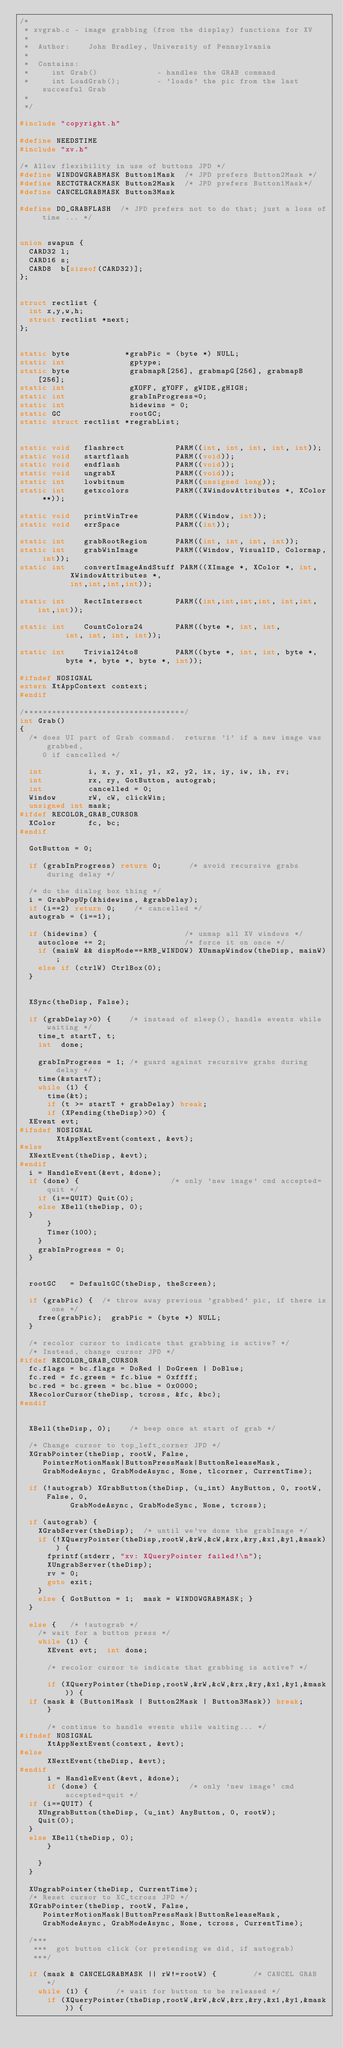Convert code to text. <code><loc_0><loc_0><loc_500><loc_500><_C_>/*
 * xvgrab.c - image grabbing (from the display) functions for XV
 *
 *  Author:    John Bradley, University of Pennsylvania
 *
 *  Contains:
 *     int Grab()             - handles the GRAB command
 *     int LoadGrab();        - 'loads' the pic from the last succesful Grab
 *
 */

#include "copyright.h"

#define NEEDSTIME
#include "xv.h"

/* Allow flexibility in use of buttons JPD */
#define WINDOWGRABMASK Button1Mask  /* JPD prefers Button2Mask */
#define RECTGTRACKMASK Button2Mask  /* JPD prefers Button1Mask*/
#define CANCELGRABMASK Button3Mask

#define DO_GRABFLASH  /* JPD prefers not to do that; just a loss of time ... */


union swapun {
  CARD32 l;
  CARD16 s;
  CARD8  b[sizeof(CARD32)];
};


struct rectlist {
  int x,y,w,h;
  struct rectlist *next;
};


static byte            *grabPic = (byte *) NULL;
static int              gptype;
static byte             grabmapR[256], grabmapG[256], grabmapB[256];
static int              gXOFF, gYOFF, gWIDE,gHIGH;
static int              grabInProgress=0;
static int              hidewins = 0;
static GC               rootGC;
static struct rectlist *regrabList;


static void   flashrect           PARM((int, int, int, int, int));
static void   startflash          PARM((void));
static void   endflash            PARM((void));
static void   ungrabX             PARM((void));
static int    lowbitnum           PARM((unsigned long));
static int    getxcolors          PARM((XWindowAttributes *, XColor **));

static void   printWinTree        PARM((Window, int));
static void   errSpace            PARM((int));

static int    grabRootRegion      PARM((int, int, int, int));
static int    grabWinImage        PARM((Window, VisualID, Colormap, int));
static int    convertImageAndStuff PARM((XImage *, XColor *, int,
					 XWindowAttributes *,
					 int,int,int,int));

static int    RectIntersect       PARM((int,int,int,int, int,int,int,int));

static int    CountColors24       PARM((byte *, int, int,
					int, int, int, int));

static int    Trivial24to8        PARM((byte *, int, int, byte *,
					byte *, byte *, byte *, int));

#ifndef NOSIGNAL
extern XtAppContext context;
#endif

/***********************************/
int Grab()
{
  /* does UI part of Grab command.  returns '1' if a new image was grabbed,
     0 if cancelled */

  int          i, x, y, x1, y1, x2, y2, ix, iy, iw, ih, rv;
  int          rx, ry, GotButton, autograb;
  int          cancelled = 0;
  Window       rW, cW, clickWin;
  unsigned int mask;
#ifdef RECOLOR_GRAB_CURSOR
  XColor       fc, bc;
#endif

  GotButton = 0;

  if (grabInProgress) return 0;      /* avoid recursive grabs during delay */

  /* do the dialog box thing */
  i = GrabPopUp(&hidewins, &grabDelay);
  if (i==2) return 0;    /* cancelled */
  autograb = (i==1);

  if (hidewins) {                   /* unmap all XV windows */
    autoclose += 2;                 /* force it on once */
    if (mainW && dispMode==RMB_WINDOW) XUnmapWindow(theDisp, mainW);
    else if (ctrlW) CtrlBox(0);
  }


  XSync(theDisp, False);

  if (grabDelay>0) {    /* instead of sleep(), handle events while waiting */
    time_t startT, t;
    int  done;

    grabInProgress = 1; /* guard against recursive grabs during delay */
    time(&startT);
    while (1) {
      time(&t);
      if (t >= startT + grabDelay) break;
      if (XPending(theDisp)>0) {
	XEvent evt;
#ifndef NOSIGNAL
        XtAppNextEvent(context, &evt);
#else
	XNextEvent(theDisp, &evt);
#endif
	i = HandleEvent(&evt, &done);
	if (done) {                    /* only 'new image' cmd accepted=quit */
	  if (i==QUIT) Quit(0);
	  else XBell(theDisp, 0);
	}
      }
      Timer(100);
    }
    grabInProgress = 0;
  }


  rootGC   = DefaultGC(theDisp, theScreen);

  if (grabPic) {  /* throw away previous 'grabbed' pic, if there is one */
    free(grabPic);  grabPic = (byte *) NULL;
  }

  /* recolor cursor to indicate that grabbing is active? */
  /* Instead, change cursor JPD */
#ifdef RECOLOR_GRAB_CURSOR
  fc.flags = bc.flags = DoRed | DoGreen | DoBlue;
  fc.red = fc.green = fc.blue = 0xffff;
  bc.red = bc.green = bc.blue = 0x0000;
  XRecolorCursor(theDisp, tcross, &fc, &bc);
#endif


  XBell(theDisp, 0);		/* beep once at start of grab */

  /* Change cursor to top_left_corner JPD */
  XGrabPointer(theDisp, rootW, False,
     PointerMotionMask|ButtonPressMask|ButtonReleaseMask,
     GrabModeAsync, GrabModeAsync, None, tlcorner, CurrentTime);

  if (!autograb) XGrabButton(theDisp, (u_int) AnyButton, 0, rootW, False, 0,
			     GrabModeAsync, GrabModeSync, None, tcross);

  if (autograb) {
    XGrabServer(theDisp);	 /* until we've done the grabImage */
    if (!XQueryPointer(theDisp,rootW,&rW,&cW,&rx,&ry,&x1,&y1,&mask)) {
      fprintf(stderr, "xv: XQueryPointer failed!\n");
      XUngrabServer(theDisp);
      rv = 0;
      goto exit;
    }
    else { GotButton = 1;  mask = WINDOWGRABMASK; }
  }

  else {   /* !autograb */
    /* wait for a button press */
    while (1) {
      XEvent evt;  int done;

      /* recolor cursor to indicate that grabbing is active? */

      if (XQueryPointer(theDisp,rootW,&rW,&cW,&rx,&ry,&x1,&y1,&mask)) {
	if (mask & (Button1Mask | Button2Mask | Button3Mask)) break;
      }

      /* continue to handle events while waiting... */
#ifndef NOSIGNAL
      XtAppNextEvent(context, &evt);
#else
      XNextEvent(theDisp, &evt);
#endif
      i = HandleEvent(&evt, &done);
      if (done) {                    /* only 'new image' cmd accepted=quit */
	if (i==QUIT) {
	  XUngrabButton(theDisp, (u_int) AnyButton, 0, rootW);
	  Quit(0);
	}
	else XBell(theDisp, 0);
      }

    }
  }

  XUngrabPointer(theDisp, CurrentTime);
  /* Reset cursor to XC_tcross JPD */
  XGrabPointer(theDisp, rootW, False,
     PointerMotionMask|ButtonPressMask|ButtonReleaseMask,
     GrabModeAsync, GrabModeAsync, None, tcross, CurrentTime);

  /***
   ***  got button click (or pretending we did, if autograb)
   ***/

  if (mask & CANCELGRABMASK || rW!=rootW) {        /* CANCEL GRAB */
    while (1) {      /* wait for button to be released */
      if (XQueryPointer(theDisp,rootW,&rW,&cW,&rx,&ry,&x1,&y1,&mask)) {</code> 